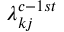Convert formula to latex. <formula><loc_0><loc_0><loc_500><loc_500>\lambda _ { k j } ^ { c - 1 s t }</formula> 